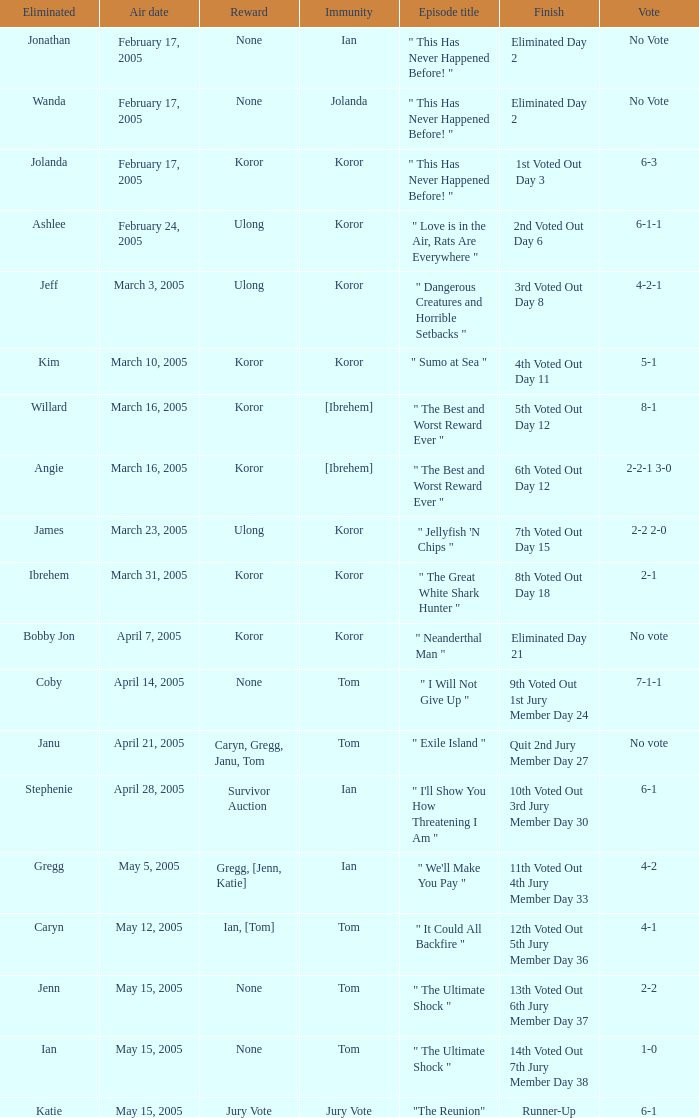What is the name of the episode in which Jenn is eliminated? " The Ultimate Shock ". 